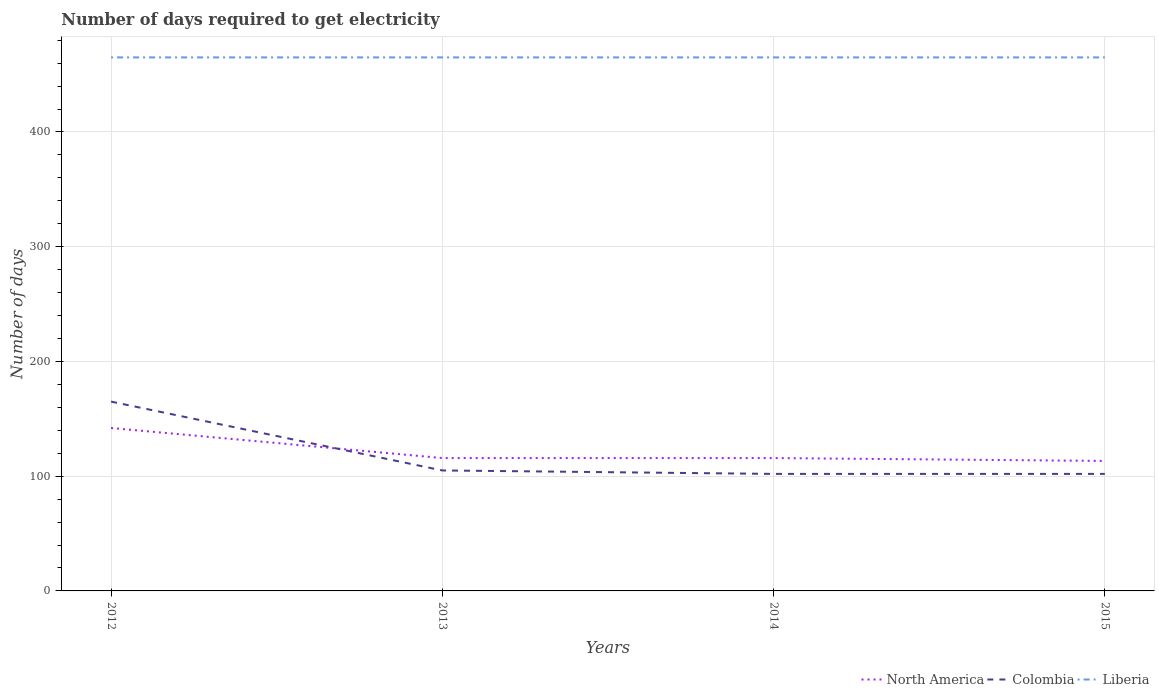How many different coloured lines are there?
Offer a very short reply. 3. Across all years, what is the maximum number of days required to get electricity in in Colombia?
Offer a terse response. 102. In which year was the number of days required to get electricity in in North America maximum?
Provide a succinct answer. 2015. What is the difference between the highest and the second highest number of days required to get electricity in in Colombia?
Provide a short and direct response. 63. Is the number of days required to get electricity in in Liberia strictly greater than the number of days required to get electricity in in Colombia over the years?
Your response must be concise. No. How many years are there in the graph?
Your response must be concise. 4. Does the graph contain grids?
Provide a succinct answer. Yes. Where does the legend appear in the graph?
Offer a very short reply. Bottom right. How are the legend labels stacked?
Keep it short and to the point. Horizontal. What is the title of the graph?
Give a very brief answer. Number of days required to get electricity. Does "Liechtenstein" appear as one of the legend labels in the graph?
Offer a terse response. No. What is the label or title of the X-axis?
Your response must be concise. Years. What is the label or title of the Y-axis?
Ensure brevity in your answer.  Number of days. What is the Number of days in North America in 2012?
Your answer should be compact. 142. What is the Number of days in Colombia in 2012?
Make the answer very short. 165. What is the Number of days in Liberia in 2012?
Your response must be concise. 465. What is the Number of days of North America in 2013?
Make the answer very short. 115.8. What is the Number of days of Colombia in 2013?
Give a very brief answer. 105. What is the Number of days in Liberia in 2013?
Make the answer very short. 465. What is the Number of days in North America in 2014?
Make the answer very short. 115.8. What is the Number of days of Colombia in 2014?
Make the answer very short. 102. What is the Number of days in Liberia in 2014?
Keep it short and to the point. 465. What is the Number of days of North America in 2015?
Provide a short and direct response. 113.3. What is the Number of days of Colombia in 2015?
Your answer should be very brief. 102. What is the Number of days of Liberia in 2015?
Your answer should be compact. 465. Across all years, what is the maximum Number of days of North America?
Offer a terse response. 142. Across all years, what is the maximum Number of days in Colombia?
Your response must be concise. 165. Across all years, what is the maximum Number of days in Liberia?
Keep it short and to the point. 465. Across all years, what is the minimum Number of days of North America?
Offer a very short reply. 113.3. Across all years, what is the minimum Number of days of Colombia?
Ensure brevity in your answer.  102. Across all years, what is the minimum Number of days in Liberia?
Offer a very short reply. 465. What is the total Number of days in North America in the graph?
Provide a succinct answer. 486.9. What is the total Number of days of Colombia in the graph?
Ensure brevity in your answer.  474. What is the total Number of days of Liberia in the graph?
Make the answer very short. 1860. What is the difference between the Number of days of North America in 2012 and that in 2013?
Keep it short and to the point. 26.2. What is the difference between the Number of days of North America in 2012 and that in 2014?
Provide a succinct answer. 26.2. What is the difference between the Number of days in Colombia in 2012 and that in 2014?
Your answer should be compact. 63. What is the difference between the Number of days in Liberia in 2012 and that in 2014?
Ensure brevity in your answer.  0. What is the difference between the Number of days in North America in 2012 and that in 2015?
Your response must be concise. 28.7. What is the difference between the Number of days of Liberia in 2012 and that in 2015?
Offer a terse response. 0. What is the difference between the Number of days of Liberia in 2013 and that in 2014?
Provide a succinct answer. 0. What is the difference between the Number of days in North America in 2013 and that in 2015?
Your answer should be very brief. 2.5. What is the difference between the Number of days of Colombia in 2013 and that in 2015?
Offer a very short reply. 3. What is the difference between the Number of days in Liberia in 2013 and that in 2015?
Keep it short and to the point. 0. What is the difference between the Number of days of Liberia in 2014 and that in 2015?
Offer a very short reply. 0. What is the difference between the Number of days in North America in 2012 and the Number of days in Colombia in 2013?
Make the answer very short. 37. What is the difference between the Number of days of North America in 2012 and the Number of days of Liberia in 2013?
Ensure brevity in your answer.  -323. What is the difference between the Number of days of Colombia in 2012 and the Number of days of Liberia in 2013?
Give a very brief answer. -300. What is the difference between the Number of days of North America in 2012 and the Number of days of Liberia in 2014?
Your answer should be compact. -323. What is the difference between the Number of days of Colombia in 2012 and the Number of days of Liberia in 2014?
Provide a short and direct response. -300. What is the difference between the Number of days in North America in 2012 and the Number of days in Liberia in 2015?
Give a very brief answer. -323. What is the difference between the Number of days of Colombia in 2012 and the Number of days of Liberia in 2015?
Make the answer very short. -300. What is the difference between the Number of days in North America in 2013 and the Number of days in Liberia in 2014?
Keep it short and to the point. -349.2. What is the difference between the Number of days in Colombia in 2013 and the Number of days in Liberia in 2014?
Your answer should be compact. -360. What is the difference between the Number of days in North America in 2013 and the Number of days in Liberia in 2015?
Provide a succinct answer. -349.2. What is the difference between the Number of days in Colombia in 2013 and the Number of days in Liberia in 2015?
Make the answer very short. -360. What is the difference between the Number of days in North America in 2014 and the Number of days in Colombia in 2015?
Offer a very short reply. 13.8. What is the difference between the Number of days in North America in 2014 and the Number of days in Liberia in 2015?
Your answer should be compact. -349.2. What is the difference between the Number of days of Colombia in 2014 and the Number of days of Liberia in 2015?
Your answer should be very brief. -363. What is the average Number of days in North America per year?
Your response must be concise. 121.72. What is the average Number of days of Colombia per year?
Your answer should be compact. 118.5. What is the average Number of days of Liberia per year?
Give a very brief answer. 465. In the year 2012, what is the difference between the Number of days in North America and Number of days in Colombia?
Offer a terse response. -23. In the year 2012, what is the difference between the Number of days of North America and Number of days of Liberia?
Provide a succinct answer. -323. In the year 2012, what is the difference between the Number of days in Colombia and Number of days in Liberia?
Make the answer very short. -300. In the year 2013, what is the difference between the Number of days of North America and Number of days of Liberia?
Give a very brief answer. -349.2. In the year 2013, what is the difference between the Number of days of Colombia and Number of days of Liberia?
Your answer should be compact. -360. In the year 2014, what is the difference between the Number of days in North America and Number of days in Liberia?
Offer a terse response. -349.2. In the year 2014, what is the difference between the Number of days in Colombia and Number of days in Liberia?
Provide a succinct answer. -363. In the year 2015, what is the difference between the Number of days of North America and Number of days of Colombia?
Give a very brief answer. 11.3. In the year 2015, what is the difference between the Number of days of North America and Number of days of Liberia?
Offer a terse response. -351.7. In the year 2015, what is the difference between the Number of days of Colombia and Number of days of Liberia?
Your answer should be compact. -363. What is the ratio of the Number of days of North America in 2012 to that in 2013?
Your answer should be compact. 1.23. What is the ratio of the Number of days in Colombia in 2012 to that in 2013?
Your answer should be compact. 1.57. What is the ratio of the Number of days in North America in 2012 to that in 2014?
Your answer should be very brief. 1.23. What is the ratio of the Number of days in Colombia in 2012 to that in 2014?
Your answer should be very brief. 1.62. What is the ratio of the Number of days in Liberia in 2012 to that in 2014?
Ensure brevity in your answer.  1. What is the ratio of the Number of days of North America in 2012 to that in 2015?
Your response must be concise. 1.25. What is the ratio of the Number of days of Colombia in 2012 to that in 2015?
Keep it short and to the point. 1.62. What is the ratio of the Number of days of Liberia in 2012 to that in 2015?
Give a very brief answer. 1. What is the ratio of the Number of days of Colombia in 2013 to that in 2014?
Provide a succinct answer. 1.03. What is the ratio of the Number of days of Liberia in 2013 to that in 2014?
Keep it short and to the point. 1. What is the ratio of the Number of days in North America in 2013 to that in 2015?
Your answer should be very brief. 1.02. What is the ratio of the Number of days in Colombia in 2013 to that in 2015?
Provide a succinct answer. 1.03. What is the ratio of the Number of days of Liberia in 2013 to that in 2015?
Keep it short and to the point. 1. What is the ratio of the Number of days in North America in 2014 to that in 2015?
Provide a short and direct response. 1.02. What is the ratio of the Number of days in Colombia in 2014 to that in 2015?
Keep it short and to the point. 1. What is the ratio of the Number of days in Liberia in 2014 to that in 2015?
Give a very brief answer. 1. What is the difference between the highest and the second highest Number of days in North America?
Offer a very short reply. 26.2. What is the difference between the highest and the lowest Number of days of North America?
Give a very brief answer. 28.7. What is the difference between the highest and the lowest Number of days in Liberia?
Your response must be concise. 0. 